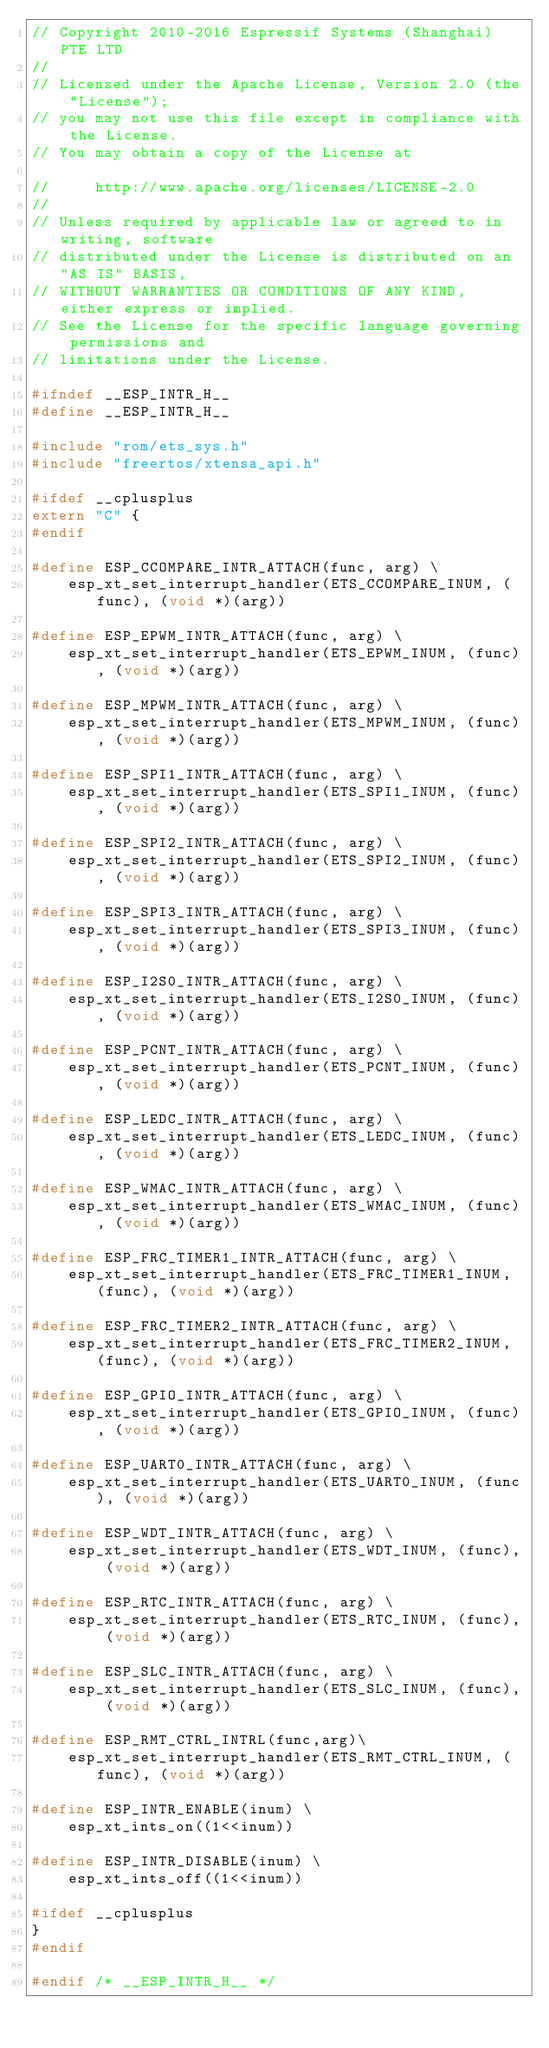<code> <loc_0><loc_0><loc_500><loc_500><_C_>// Copyright 2010-2016 Espressif Systems (Shanghai) PTE LTD
//
// Licensed under the Apache License, Version 2.0 (the "License");
// you may not use this file except in compliance with the License.
// You may obtain a copy of the License at

//     http://www.apache.org/licenses/LICENSE-2.0
//
// Unless required by applicable law or agreed to in writing, software
// distributed under the License is distributed on an "AS IS" BASIS,
// WITHOUT WARRANTIES OR CONDITIONS OF ANY KIND, either express or implied.
// See the License for the specific language governing permissions and
// limitations under the License.

#ifndef __ESP_INTR_H__
#define __ESP_INTR_H__

#include "rom/ets_sys.h"
#include "freertos/xtensa_api.h"

#ifdef __cplusplus
extern "C" {
#endif

#define ESP_CCOMPARE_INTR_ATTACH(func, arg) \
    esp_xt_set_interrupt_handler(ETS_CCOMPARE_INUM, (func), (void *)(arg))

#define ESP_EPWM_INTR_ATTACH(func, arg) \
    esp_xt_set_interrupt_handler(ETS_EPWM_INUM, (func), (void *)(arg))

#define ESP_MPWM_INTR_ATTACH(func, arg) \
    esp_xt_set_interrupt_handler(ETS_MPWM_INUM, (func), (void *)(arg))

#define ESP_SPI1_INTR_ATTACH(func, arg) \
    esp_xt_set_interrupt_handler(ETS_SPI1_INUM, (func), (void *)(arg))

#define ESP_SPI2_INTR_ATTACH(func, arg) \
    esp_xt_set_interrupt_handler(ETS_SPI2_INUM, (func), (void *)(arg))

#define ESP_SPI3_INTR_ATTACH(func, arg) \
    esp_xt_set_interrupt_handler(ETS_SPI3_INUM, (func), (void *)(arg))

#define ESP_I2S0_INTR_ATTACH(func, arg) \
    esp_xt_set_interrupt_handler(ETS_I2S0_INUM, (func), (void *)(arg))

#define ESP_PCNT_INTR_ATTACH(func, arg) \
    esp_xt_set_interrupt_handler(ETS_PCNT_INUM, (func), (void *)(arg))

#define ESP_LEDC_INTR_ATTACH(func, arg) \
    esp_xt_set_interrupt_handler(ETS_LEDC_INUM, (func), (void *)(arg))

#define ESP_WMAC_INTR_ATTACH(func, arg) \
    esp_xt_set_interrupt_handler(ETS_WMAC_INUM, (func), (void *)(arg))

#define ESP_FRC_TIMER1_INTR_ATTACH(func, arg) \
    esp_xt_set_interrupt_handler(ETS_FRC_TIMER1_INUM, (func), (void *)(arg))

#define ESP_FRC_TIMER2_INTR_ATTACH(func, arg) \
    esp_xt_set_interrupt_handler(ETS_FRC_TIMER2_INUM, (func), (void *)(arg))

#define ESP_GPIO_INTR_ATTACH(func, arg) \
    esp_xt_set_interrupt_handler(ETS_GPIO_INUM, (func), (void *)(arg))

#define ESP_UART0_INTR_ATTACH(func, arg) \
    esp_xt_set_interrupt_handler(ETS_UART0_INUM, (func), (void *)(arg))

#define ESP_WDT_INTR_ATTACH(func, arg) \
    esp_xt_set_interrupt_handler(ETS_WDT_INUM, (func), (void *)(arg))

#define ESP_RTC_INTR_ATTACH(func, arg) \
    esp_xt_set_interrupt_handler(ETS_RTC_INUM, (func), (void *)(arg))

#define ESP_SLC_INTR_ATTACH(func, arg) \
    esp_xt_set_interrupt_handler(ETS_SLC_INUM, (func), (void *)(arg))

#define ESP_RMT_CTRL_INTRL(func,arg)\
    esp_xt_set_interrupt_handler(ETS_RMT_CTRL_INUM, (func), (void *)(arg))

#define ESP_INTR_ENABLE(inum) \
    esp_xt_ints_on((1<<inum))

#define ESP_INTR_DISABLE(inum) \
    esp_xt_ints_off((1<<inum))

#ifdef __cplusplus
}
#endif

#endif /* __ESP_INTR_H__ */
</code> 